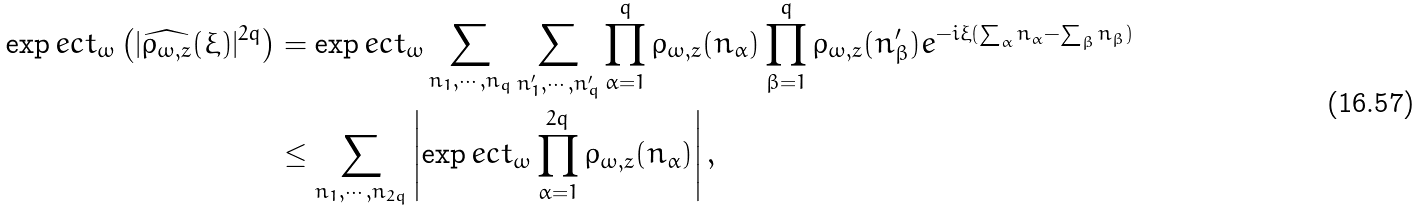<formula> <loc_0><loc_0><loc_500><loc_500>\exp e c t _ { \omega } \left ( | \widehat { \rho _ { \omega , z } } ( \xi ) | ^ { 2 q } \right ) & = \exp e c t _ { \omega } \sum _ { n _ { 1 } , \cdots , n _ { q } } \sum _ { n ^ { \prime } _ { 1 } , \cdots , n ^ { \prime } _ { q } } \prod _ { \alpha = 1 } ^ { q } \rho _ { \omega , z } ( n _ { \alpha } ) \prod _ { \beta = 1 } ^ { q } \rho _ { \omega , z } ( n ^ { \prime } _ { \beta } ) e ^ { - i \xi ( \sum _ { \alpha } n _ { \alpha } - \sum _ { \beta } n _ { \beta } ) } \\ & \leq \sum _ { n _ { 1 } , \cdots , n _ { 2 q } } \left | \exp e c t _ { \omega } \prod _ { \alpha = 1 } ^ { 2 q } \rho _ { \omega , z } ( n _ { \alpha } ) \right | ,</formula> 